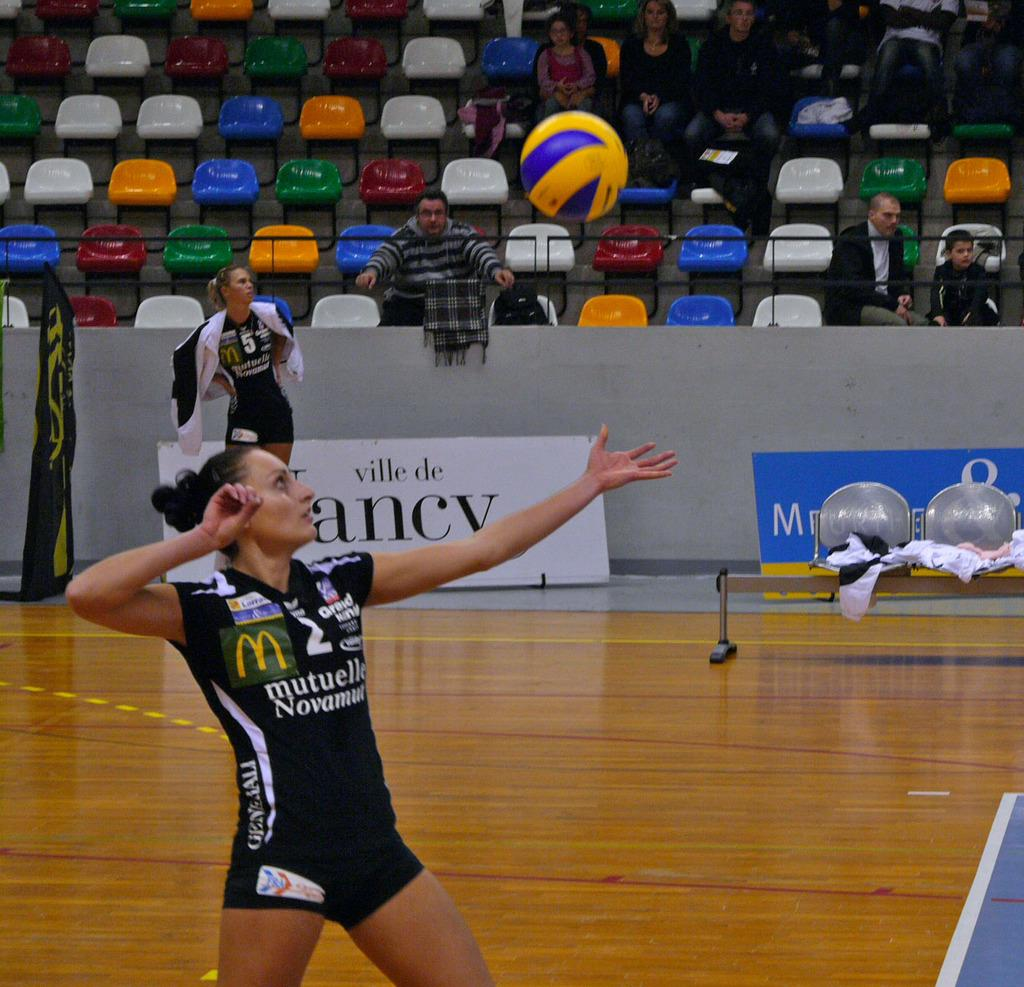Provide a one-sentence caption for the provided image. Female volleyball player #2 wearing jersey with McDonald's logo. 